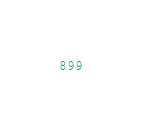<code> <loc_0><loc_0><loc_500><loc_500><_Java_>
</code> 